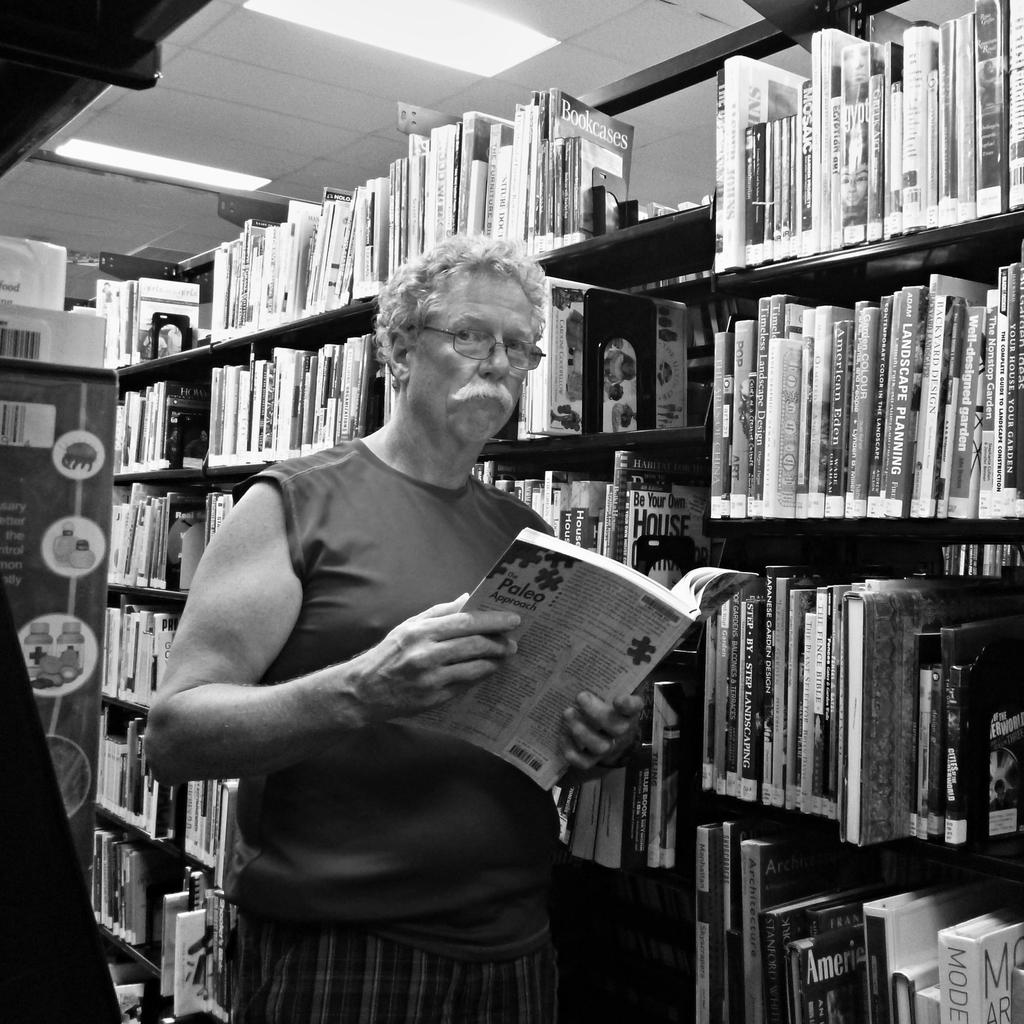What is the man in the image doing? The man is standing in the image and holding a book. What else can be seen in the image related to books? There are books on a shelf in the image, and the books have text on them. What is visible at the top of the image? There are lights visible at the top of the image. What type of war is being discussed in the book the man is holding? There is no indication in the image that the book the man is holding is about any war. 